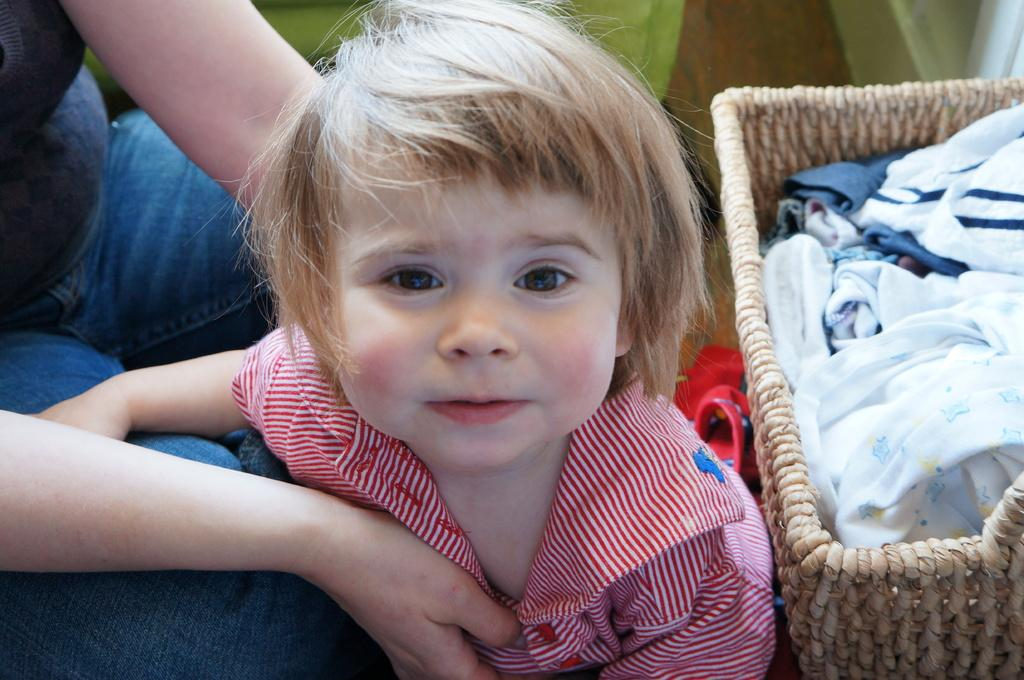Who is the main subject in the image? There is a little girl in the image. What is the girl wearing? The girl is wearing a white and red color t-shirt. What can be seen on the right side of the image? There is a basket with clothes on the right side of the image. What type of chalk is the girl using to draw on the wall in the image? There is no chalk or drawing on the wall present in the image. What meal is the girl eating in the image? The image does not show the girl eating any meal. 